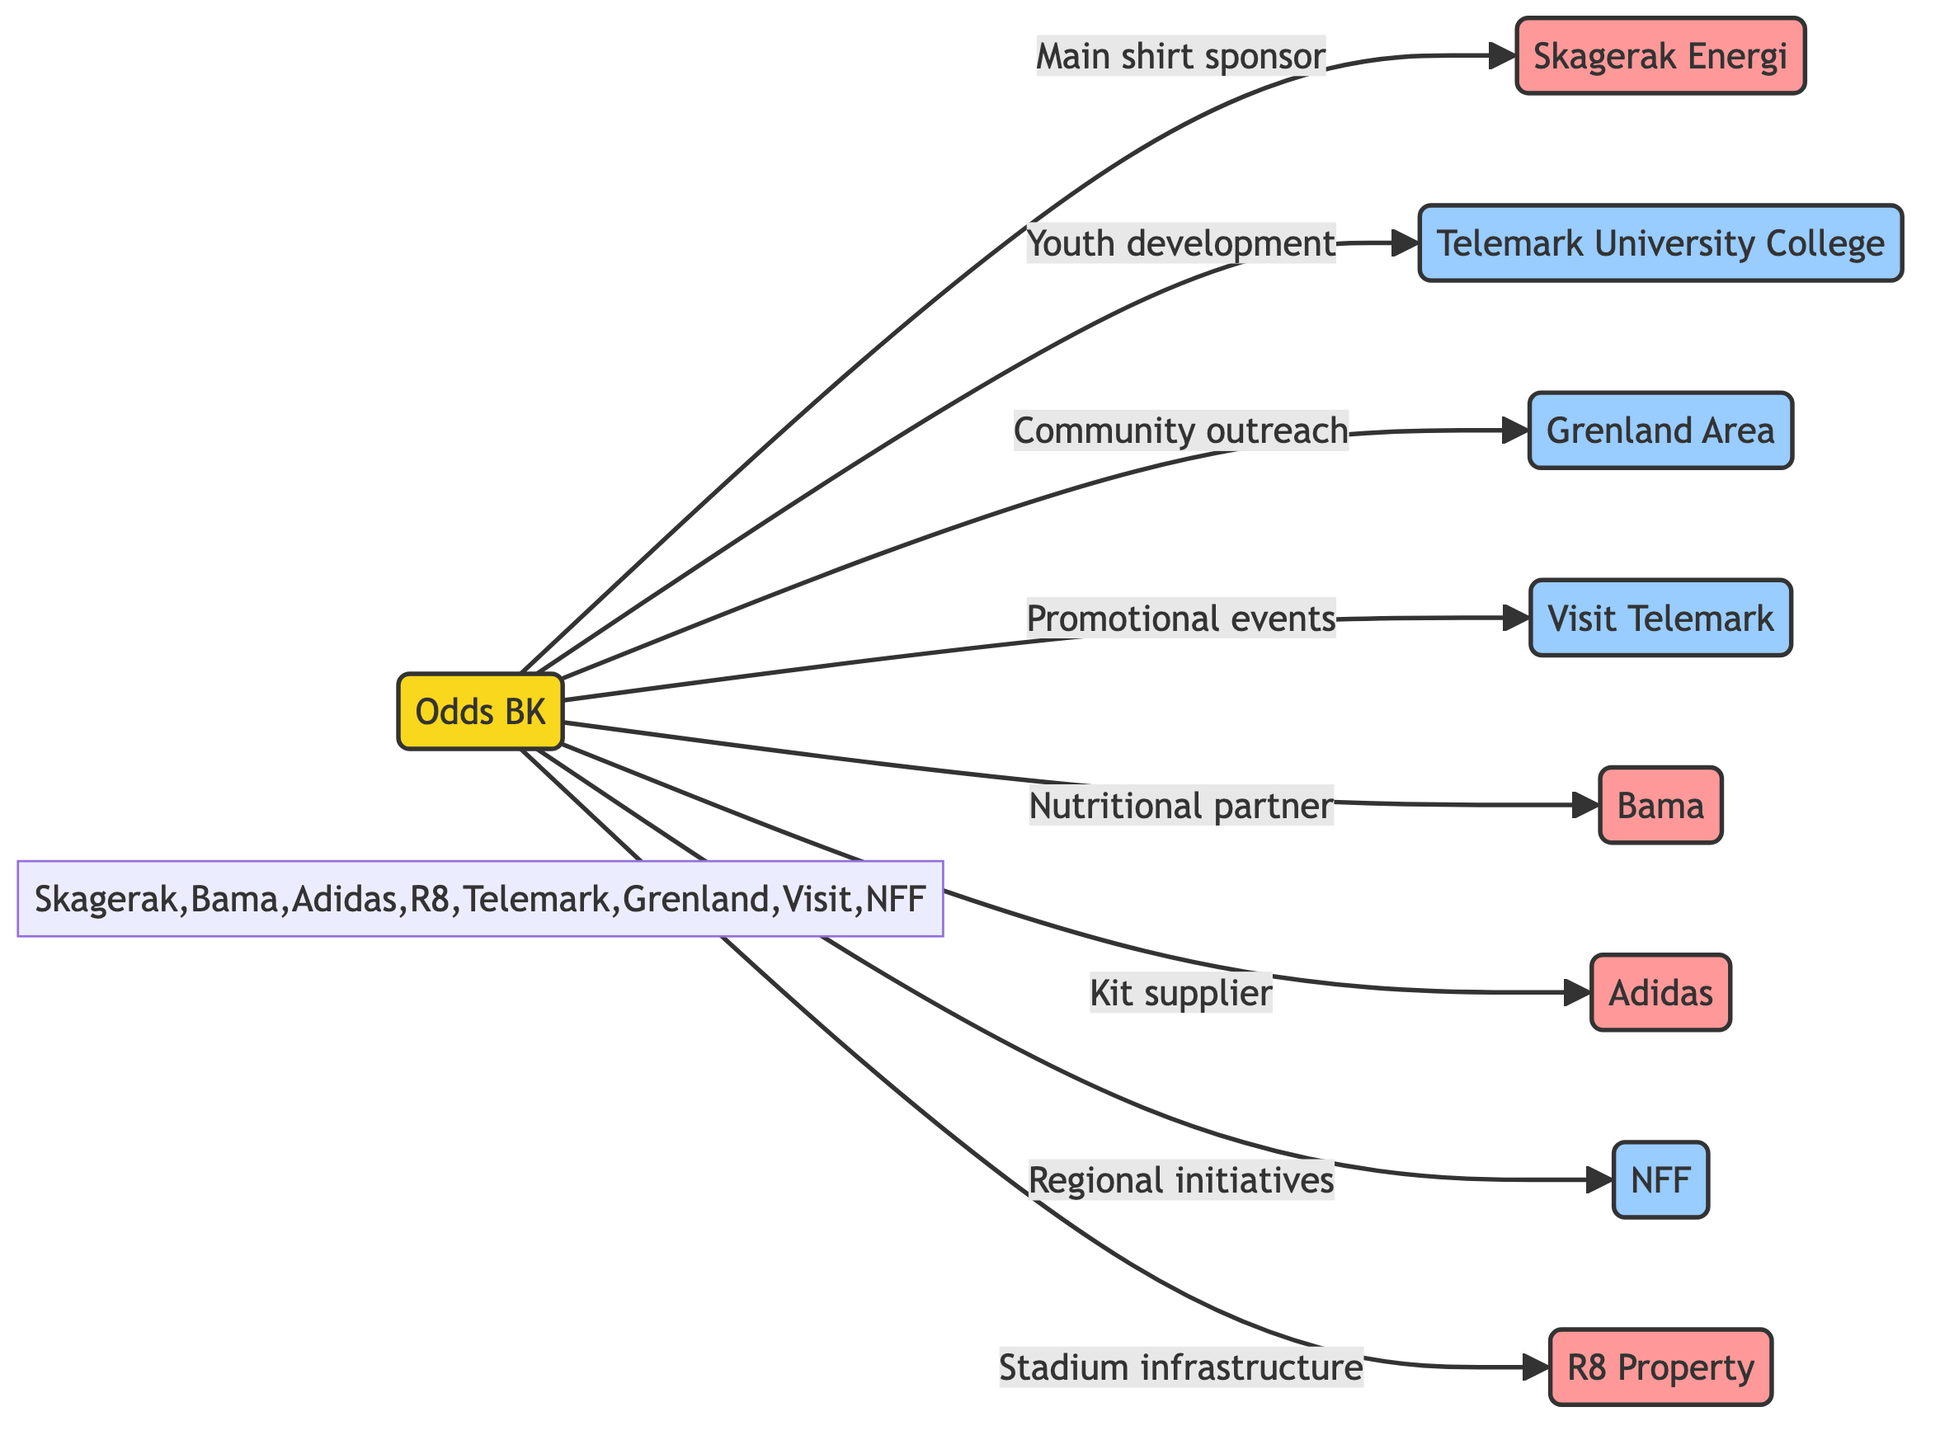What is the total number of nodes in the diagram? The diagram contains a total of 9 nodes, which include 1 club (Odds BK), 4 sponsors (Skagerak Energi, Bama, Adidas, R8 Property), and 4 partners (Telemark University College, Grenland Area, Visit Telemark, NFF).
Answer: 9 What type of deal is represented between Odds BK and Skagerak Energi? The edge connecting Odds BK and Skagerak Energi is labeled as a "sponsorship deal" indicating their relationship.
Answer: sponsorship deal Which organization is the main shirt sponsor for the 2023 season? The diagram specifies that Skagerak Energi is the "Main shirt sponsor for 2023 season," showing its significant role in sponsorship for Odds BK.
Answer: Skagerak Energi How many sponsorship deals are listed in the diagram? By reviewing the edges in the diagram, there are 4 sponsorship deals connecting Odds BK to its sponsors (Skagerak Energi, Bama, Adidas, R8 Property).
Answer: 4 What type of relationship exists between Odds BK and Telemark University College? The diagram indicates that the relationship between Odds BK and Telemark University College is characterized as a "partnership," showing a collaborative effort in youth development and education.
Answer: partnership Which sponsor is involved in providing nutritional products? The connection labeled "Nutritional partner providing fresh produce" indicates that Bama is the sponsor involved in this service for Odds BK.
Answer: Bama What is the collaboration focus between Odds BK and Visit Telemark? The edge between Odds BK and Visit Telemark specifies "Promotional events and tourism initiatives," indicating the nature of their collaboration.
Answer: Promotional events and tourism initiatives How many partners are collaborating with Odds BK according to the diagram? There are 4 partners collaborating with Odds BK as indicated by the edges to Telemark University College, Grenland Area, Visit Telemark, and NFF.
Answer: 4 What type of connection is there between Odds BK and NFF? The connection type between Odds BK and NFF is classified as a "partnership," highlighting their cooperative involvement in football initiatives.
Answer: partnership 